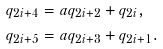Convert formula to latex. <formula><loc_0><loc_0><loc_500><loc_500>q _ { 2 i + 4 } & = a q _ { 2 i + 2 } + q _ { 2 i } , \\ q _ { 2 i + 5 } & = a q _ { 2 i + 3 } + q _ { 2 i + 1 } .</formula> 